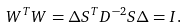Convert formula to latex. <formula><loc_0><loc_0><loc_500><loc_500>W ^ { T } W = \Delta S ^ { T } D ^ { - 2 } S \Delta = I .</formula> 